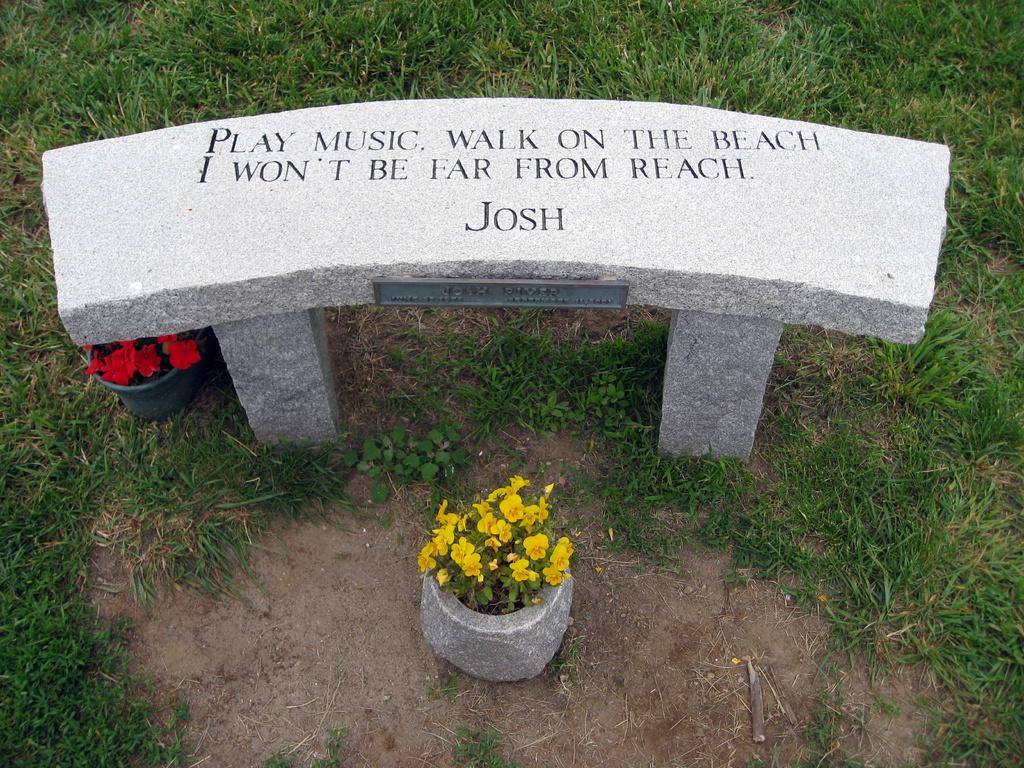How many flower pots are visible in the image? There are two flower pots in the image. What is written or depicted on the rock structure in the image? There is text on a rock structure in the image. What type of vegetation can be seen on the surface in the image? There is grass on the surface in the image. Can you see a yak grazing on the celery in the image? No, there is no yak or celery present in the image. Is the image taken inside a home? The provided facts do not mention any information about the location being a home, so we cannot definitively answer this question. 